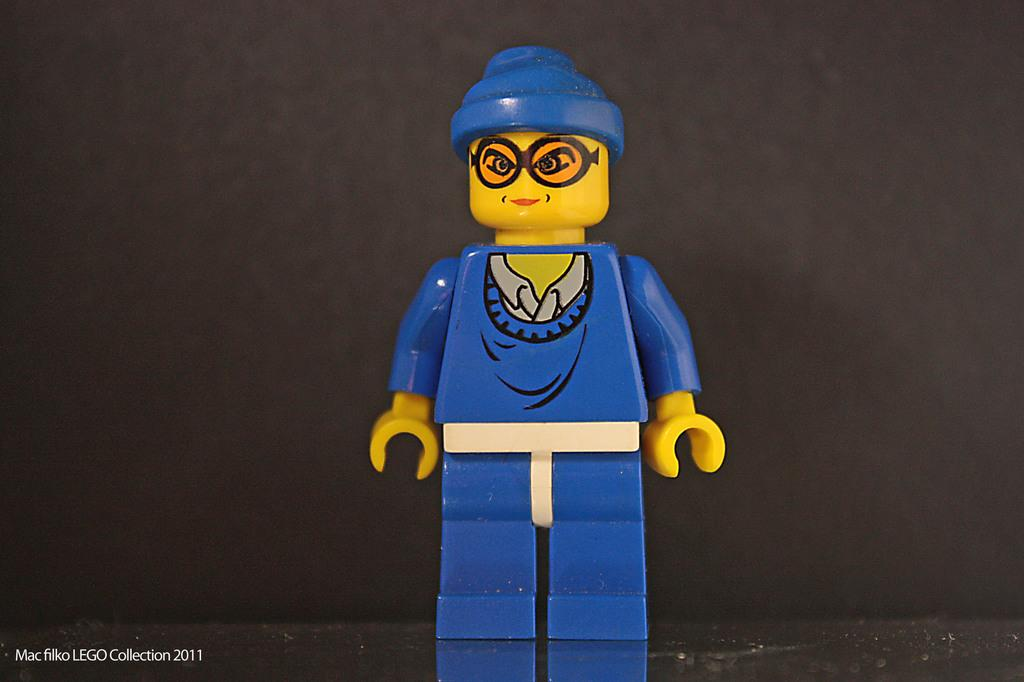What object can be seen in the image? There is a toy in the image. What is the color of the toy? The toy is blue in color. What type of joke can be seen in the image? There is no joke present in the image; it features a blue toy. What kind of space-related object can be seen in the image? There is no space-related object present in the image; it features a blue toy. 